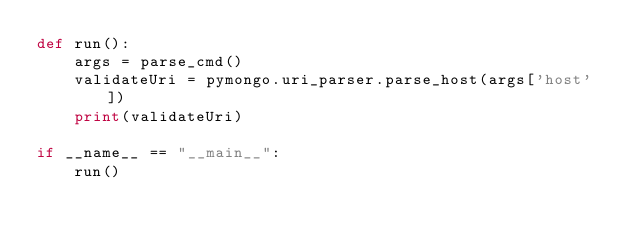Convert code to text. <code><loc_0><loc_0><loc_500><loc_500><_Python_>def run():
    args = parse_cmd()
    validateUri = pymongo.uri_parser.parse_host(args['host'])
    print(validateUri)

if __name__ == "__main__":
    run()

</code> 